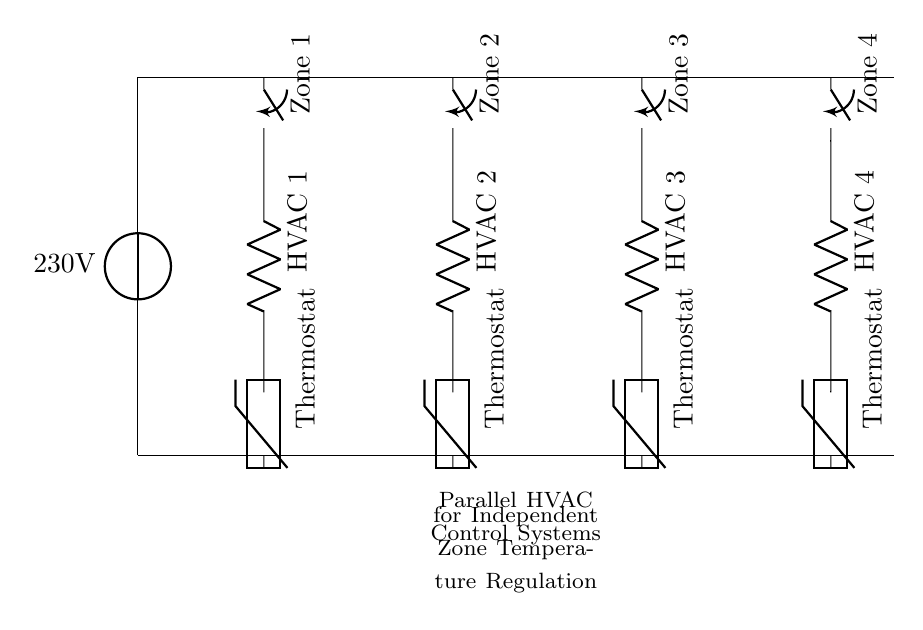What voltage is supplied to the HVAC systems? The main power supply connected to the circuit indicates a voltage of 230 volts, which is the voltage supplied to all HVAC systems in this arrangement.
Answer: 230V How many HVAC zones are represented in the circuit? There are four distinct zones in the circuit, each represented by a switch, a resistor labeled as HVAC, and a thermostat for independent control.
Answer: 4 What type of control component is used for temperature regulation? The circuit shows that thermistors are used as the control components, positioned after each HVAC unit to regulate the temperature in each zone based on the detected temperature.
Answer: Thermistor What is the purpose of connecting the HVAC systems in parallel? Connecting the HVAC systems in parallel allows each zone to function independently, which means that each thermostat can control its corresponding HVAC unit without affecting the others, enabling tailored temperature settings.
Answer: Independent control What does each HVAC unit consist of in this circuit? Each HVAC unit in the diagram is illustrated as a resistor (R), representing the heating or cooling device in that particular zone.
Answer: Resistor 